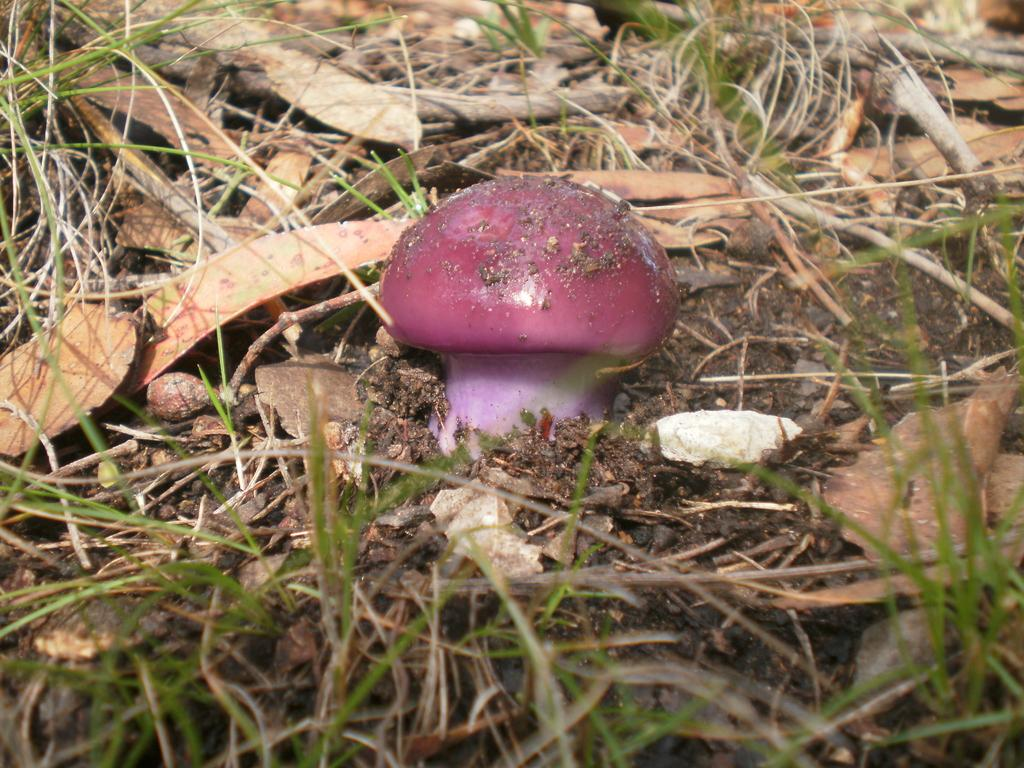What type of plant is present in the picture? There is a mushroom in the picture. What else can be seen on the ground in the picture? There are broken wooden blocks visible in the picture. What is the color of the grass in the picture? There is green grass visible in the picture. What type of material is present on the soil in the picture? There are stones on the soil in the picture. What activity is the son participating in with the balloon in the picture? There is no son or balloon present in the picture. 